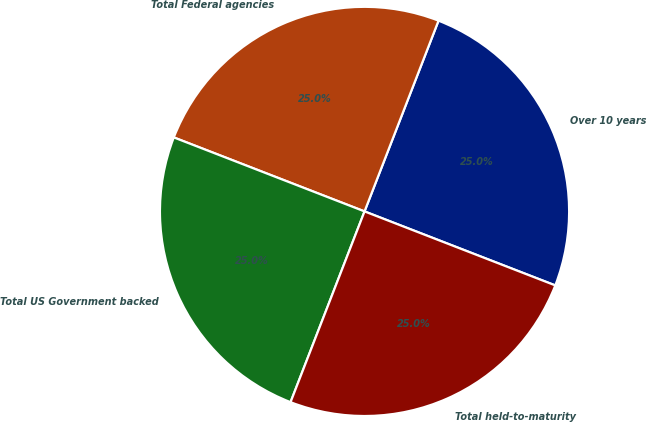Convert chart. <chart><loc_0><loc_0><loc_500><loc_500><pie_chart><fcel>Over 10 years<fcel>Total Federal agencies<fcel>Total US Government backed<fcel>Total held-to-maturity<nl><fcel>25.0%<fcel>25.0%<fcel>25.0%<fcel>25.0%<nl></chart> 